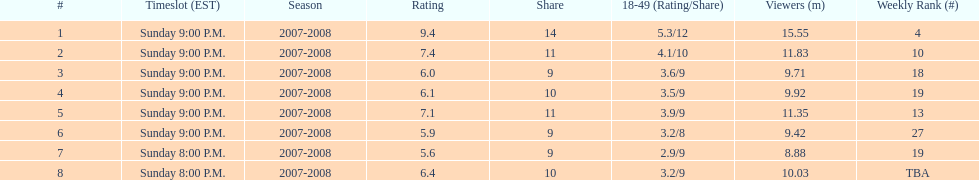What episode had the highest rating? March 2, 2008. Write the full table. {'header': ['#', 'Timeslot (EST)', 'Season', 'Rating', 'Share', '18-49 (Rating/Share)', 'Viewers (m)', 'Weekly Rank (#)'], 'rows': [['1', 'Sunday 9:00 P.M.', '2007-2008', '9.4', '14', '5.3/12', '15.55', '4'], ['2', 'Sunday 9:00 P.M.', '2007-2008', '7.4', '11', '4.1/10', '11.83', '10'], ['3', 'Sunday 9:00 P.M.', '2007-2008', '6.0', '9', '3.6/9', '9.71', '18'], ['4', 'Sunday 9:00 P.M.', '2007-2008', '6.1', '10', '3.5/9', '9.92', '19'], ['5', 'Sunday 9:00 P.M.', '2007-2008', '7.1', '11', '3.9/9', '11.35', '13'], ['6', 'Sunday 9:00 P.M.', '2007-2008', '5.9', '9', '3.2/8', '9.42', '27'], ['7', 'Sunday 8:00 P.M.', '2007-2008', '5.6', '9', '2.9/9', '8.88', '19'], ['8', 'Sunday 8:00 P.M.', '2007-2008', '6.4', '10', '3.2/9', '10.03', 'TBA']]} 